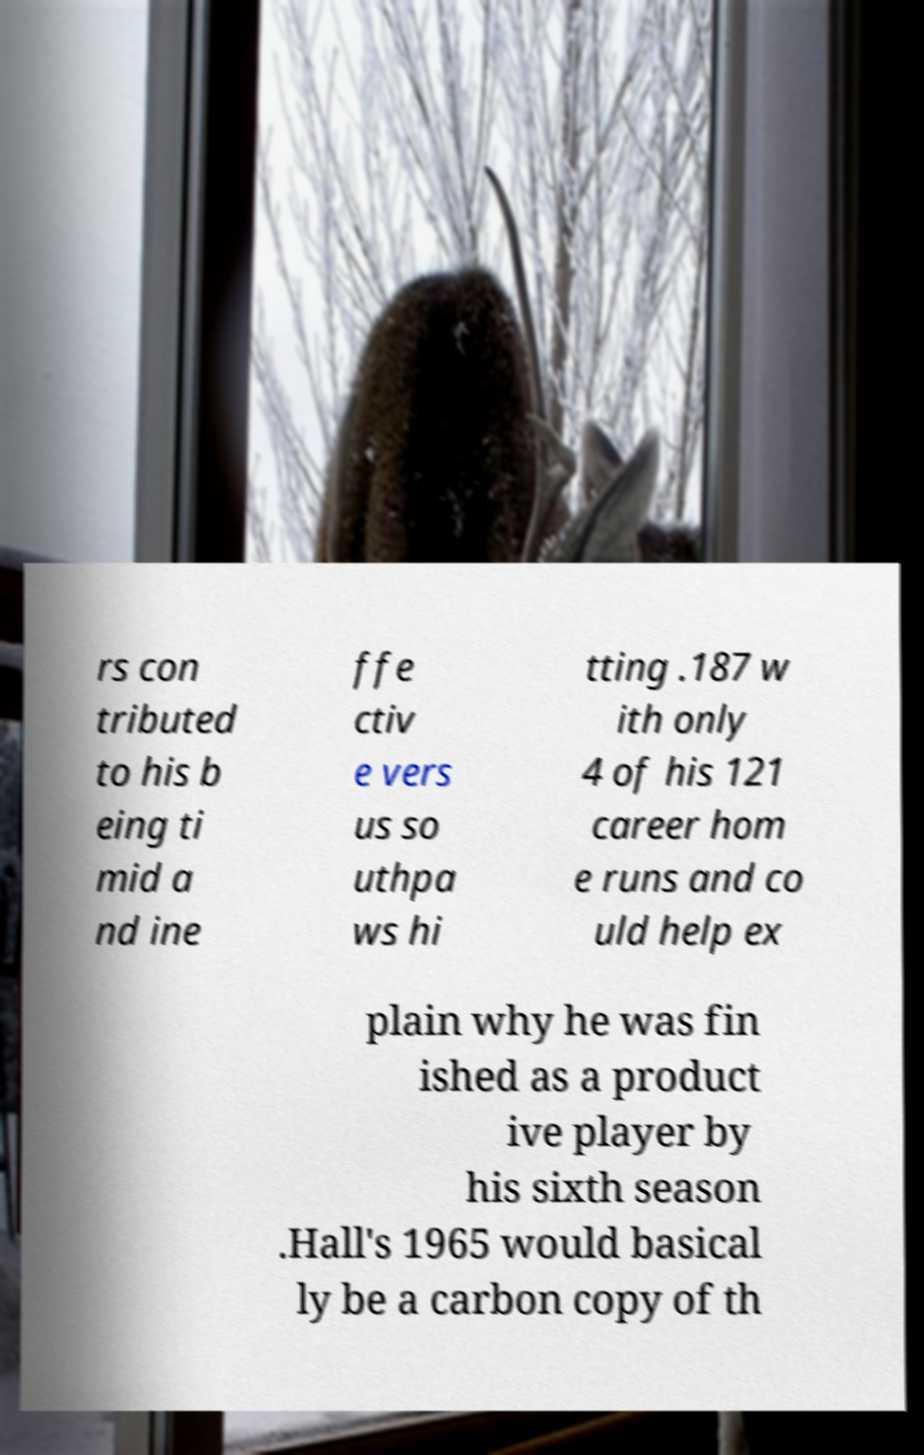There's text embedded in this image that I need extracted. Can you transcribe it verbatim? rs con tributed to his b eing ti mid a nd ine ffe ctiv e vers us so uthpa ws hi tting .187 w ith only 4 of his 121 career hom e runs and co uld help ex plain why he was fin ished as a product ive player by his sixth season .Hall's 1965 would basical ly be a carbon copy of th 